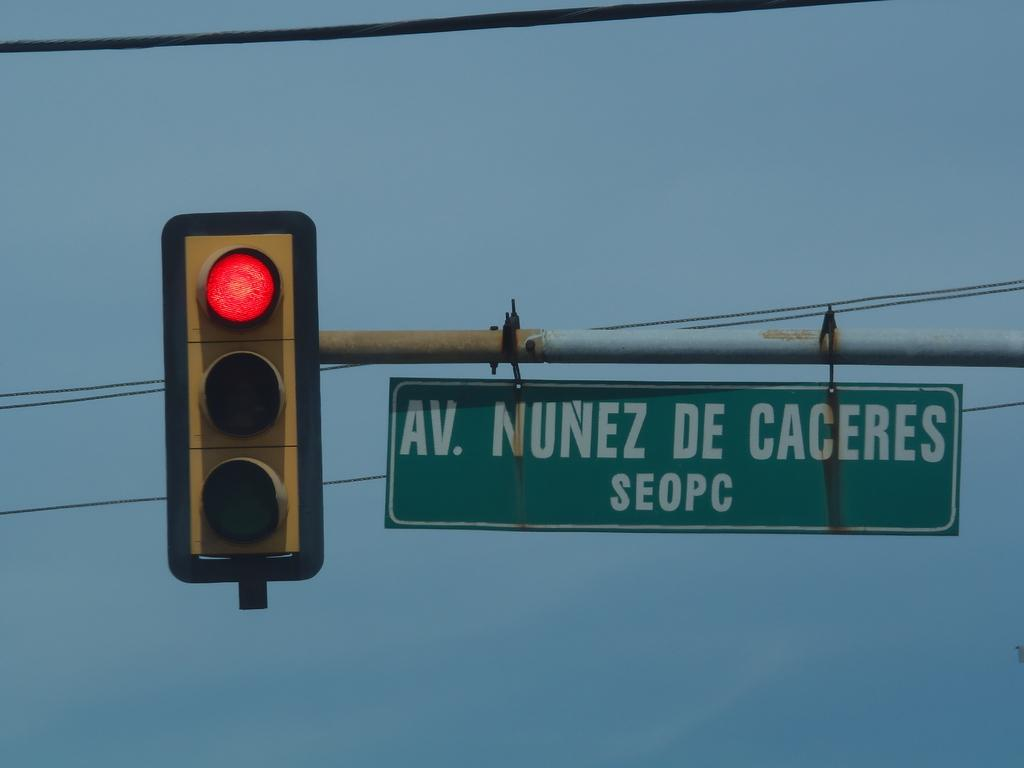<image>
Relay a brief, clear account of the picture shown. A traffic light which show red with a green sign on right with AV. NUNEZ DE CACERES written on it. 